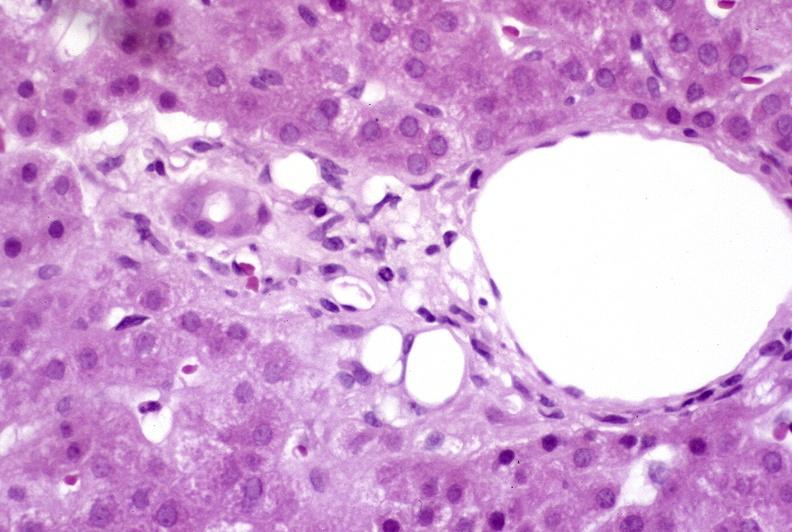s hepatobiliary present?
Answer the question using a single word or phrase. Yes 